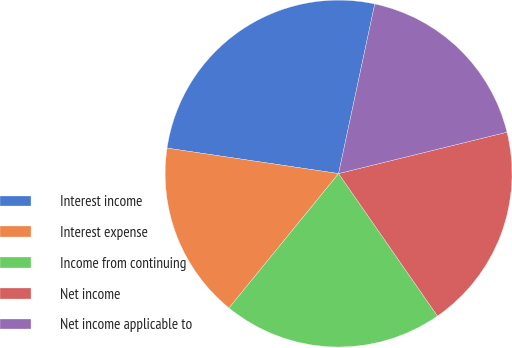Convert chart to OTSL. <chart><loc_0><loc_0><loc_500><loc_500><pie_chart><fcel>Interest income<fcel>Interest expense<fcel>Income from continuing<fcel>Net income<fcel>Net income applicable to<nl><fcel>26.0%<fcel>16.46%<fcel>20.54%<fcel>19.18%<fcel>17.82%<nl></chart> 